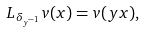<formula> <loc_0><loc_0><loc_500><loc_500>L _ { \delta _ { y ^ { - 1 } } } v ( x ) = v ( y x ) ,</formula> 